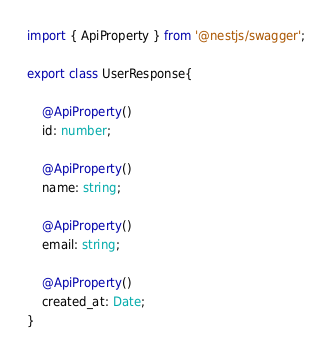<code> <loc_0><loc_0><loc_500><loc_500><_TypeScript_>import { ApiProperty } from '@nestjs/swagger';

export class UserResponse{
    
    @ApiProperty()
    id: number;

    @ApiProperty()
    name: string;

    @ApiProperty()
    email: string;

    @ApiProperty()
    created_at: Date;
}</code> 